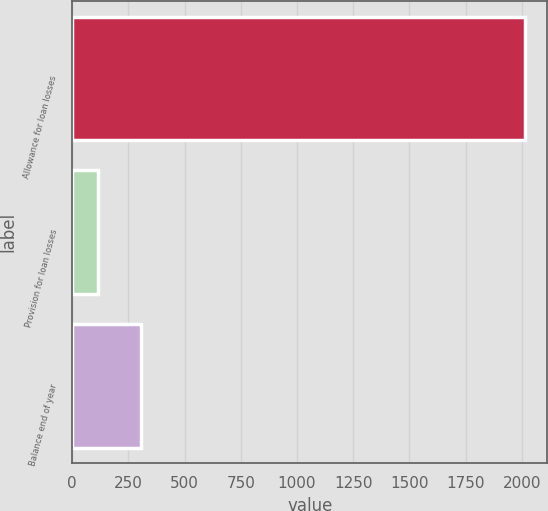Convert chart to OTSL. <chart><loc_0><loc_0><loc_500><loc_500><bar_chart><fcel>Allowance for loan losses<fcel>Provision for loan losses<fcel>Balance end of year<nl><fcel>2013<fcel>115<fcel>304.8<nl></chart> 